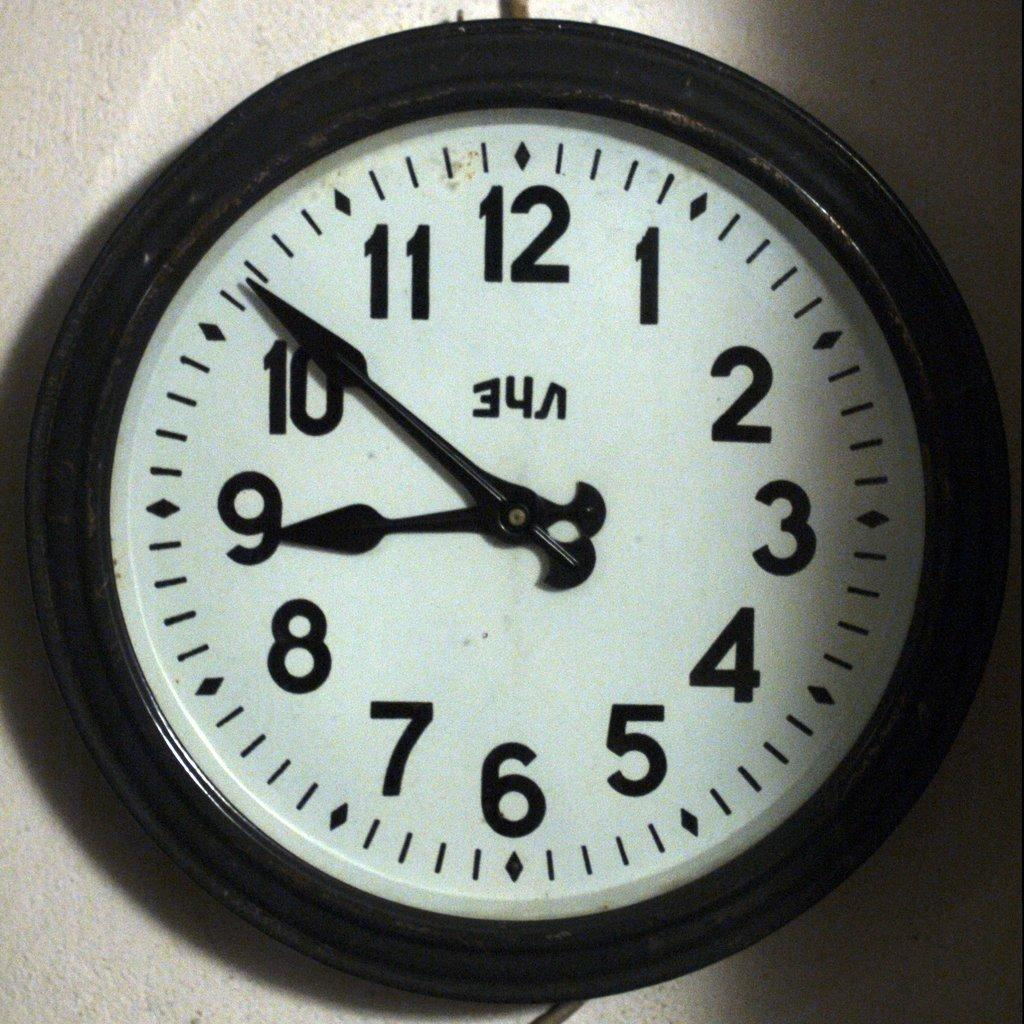<image>
Present a compact description of the photo's key features. An analog clock with the numbers 1-12 on it. 